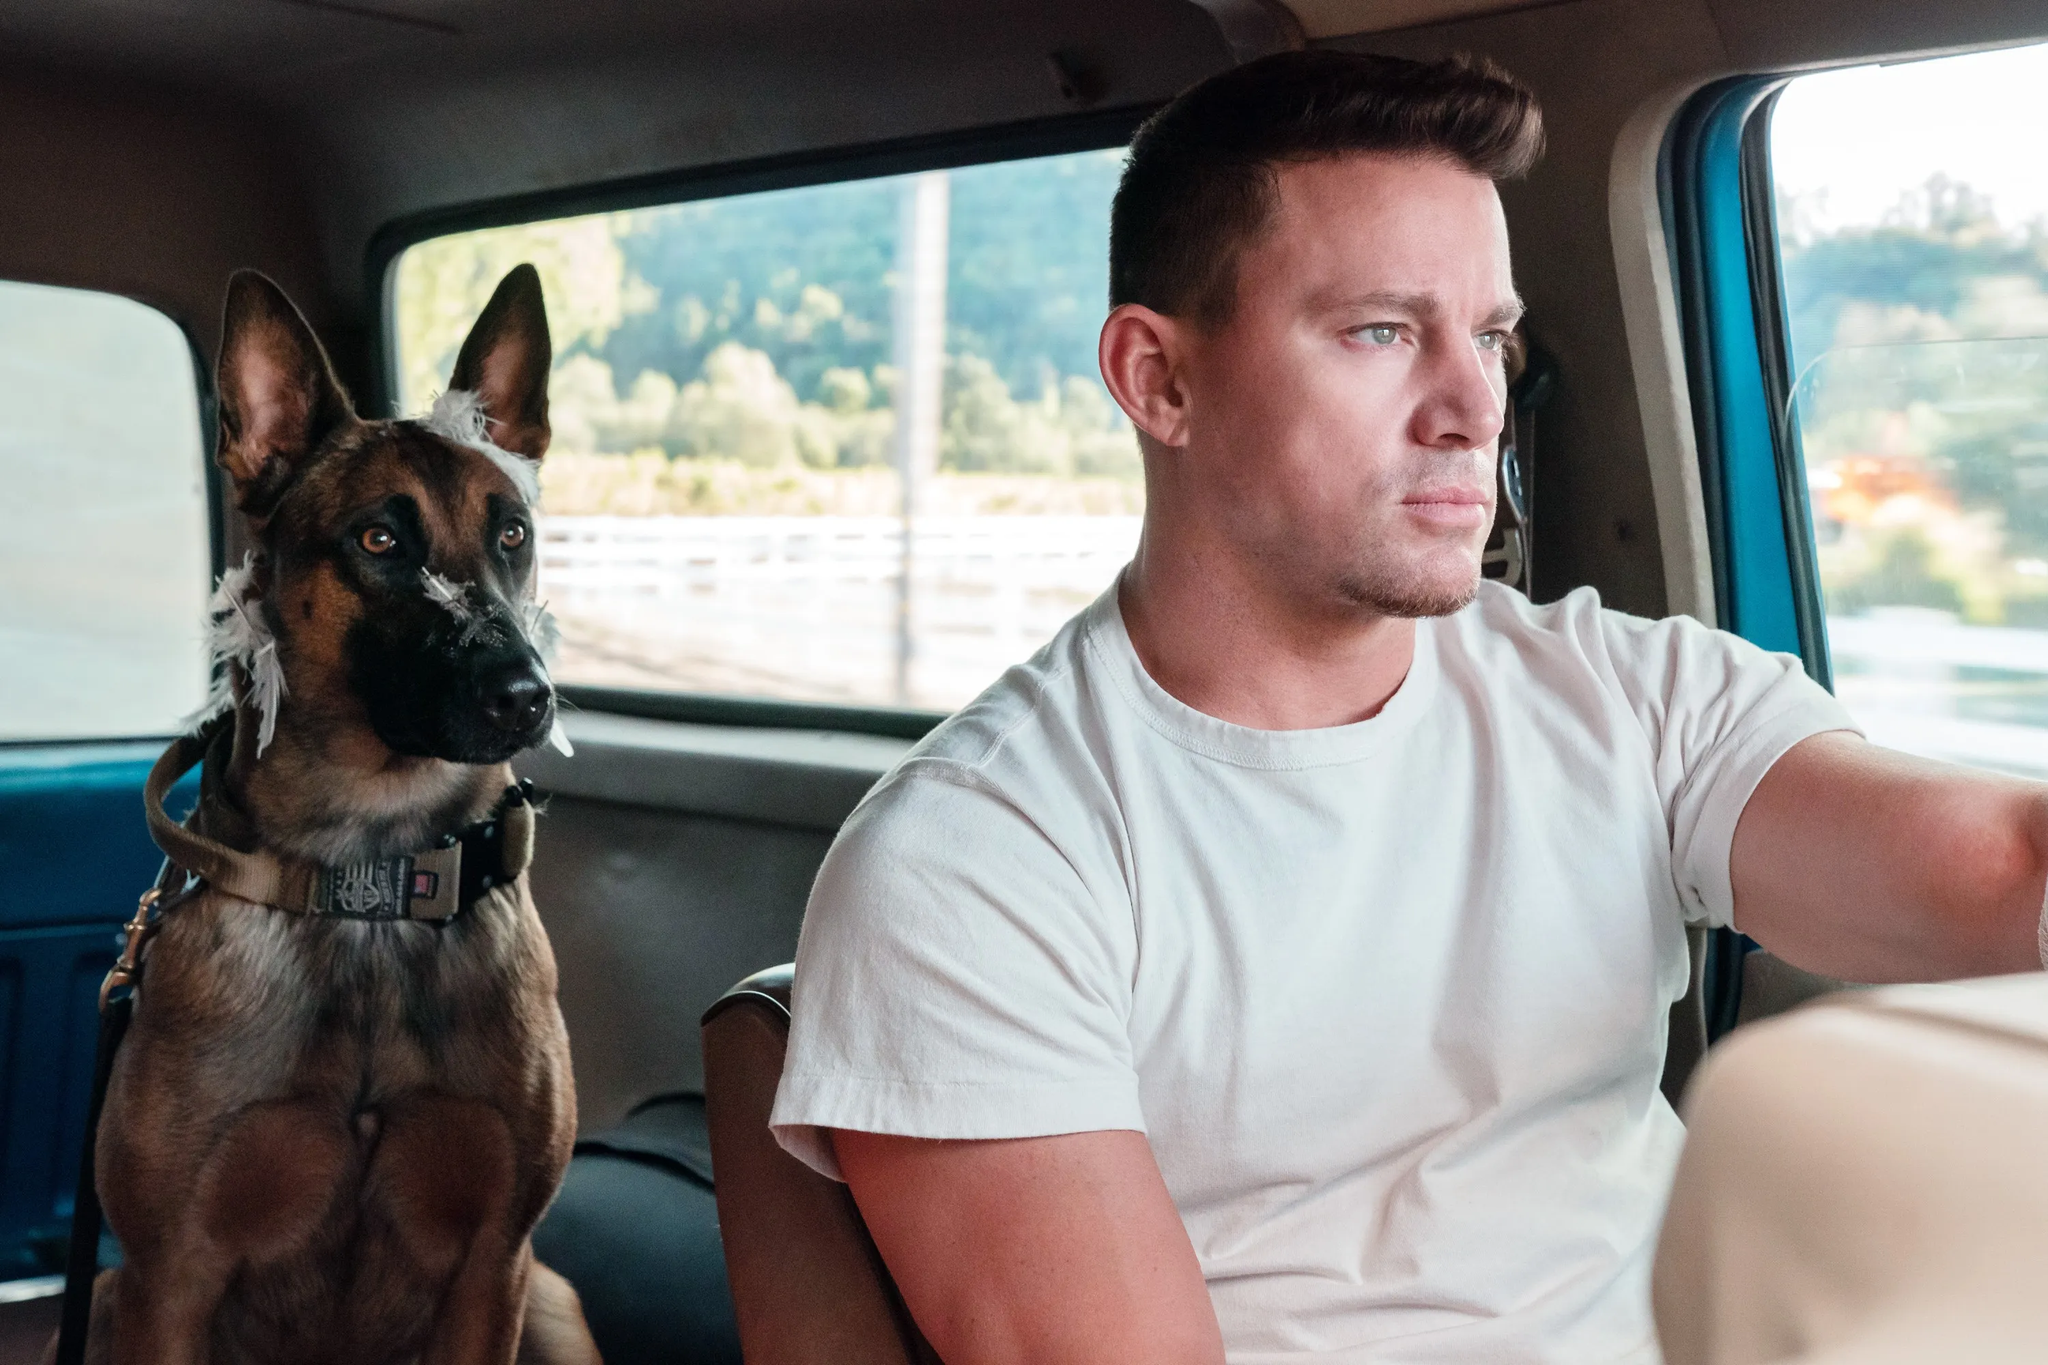What is the significance of having a dog as a travel companion? Having a dog as a travel companion can significantly enhance the overall experience of a trip. Dogs often provide emotional support, reduce stress, and encourage more frequent stops to explore surroundings, potentially leading to more adventure. Moreover, a dog's presence can add a sense of security and companionship, making the journey feel more enjoyable and less solitary. 